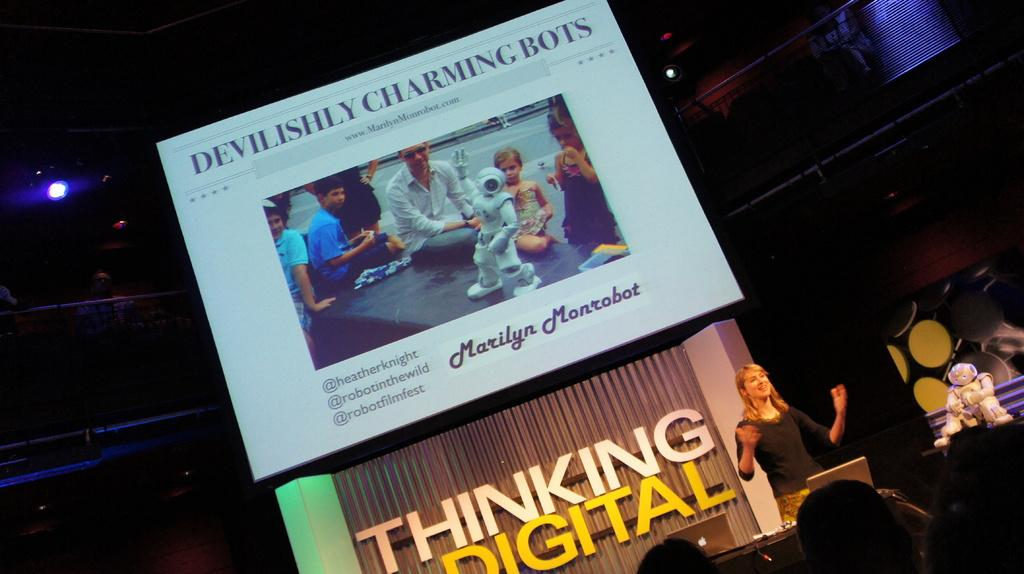Provide a one-sentence caption for the provided image. A lecturer delivers a talk on the subject of robots. 